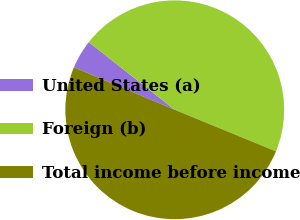Convert chart. <chart><loc_0><loc_0><loc_500><loc_500><pie_chart><fcel>United States (a)<fcel>Foreign (b)<fcel>Total income before income<nl><fcel>4.27%<fcel>45.58%<fcel>50.14%<nl></chart> 